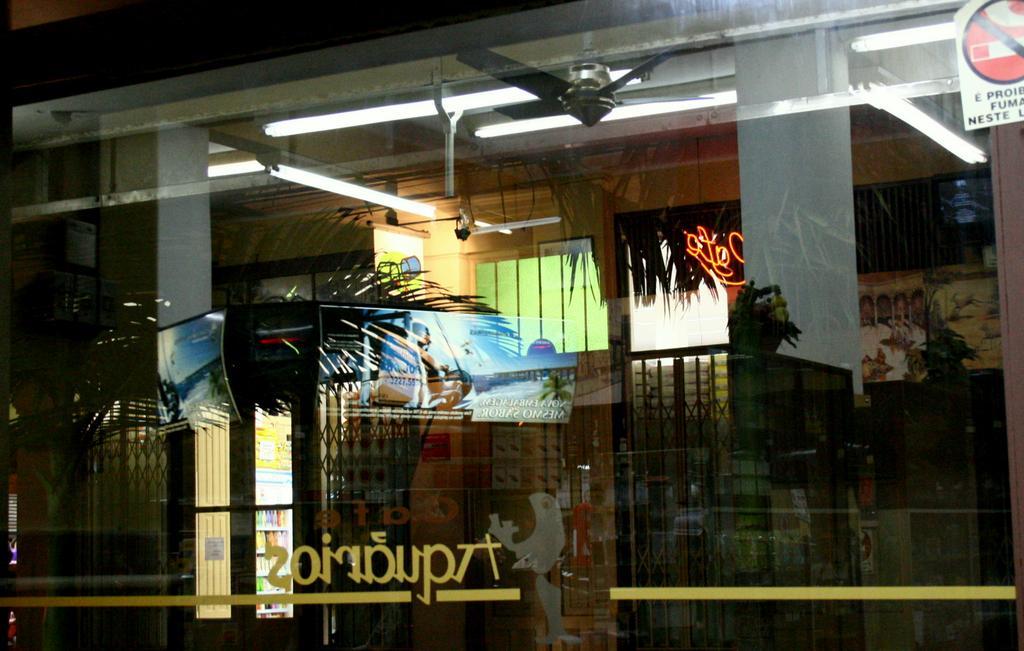How would you summarize this image in a sentence or two? In this picture, it seems like a glass window in the center, where we can see the reflection of trees, metal gate, fan, light and stalls. 